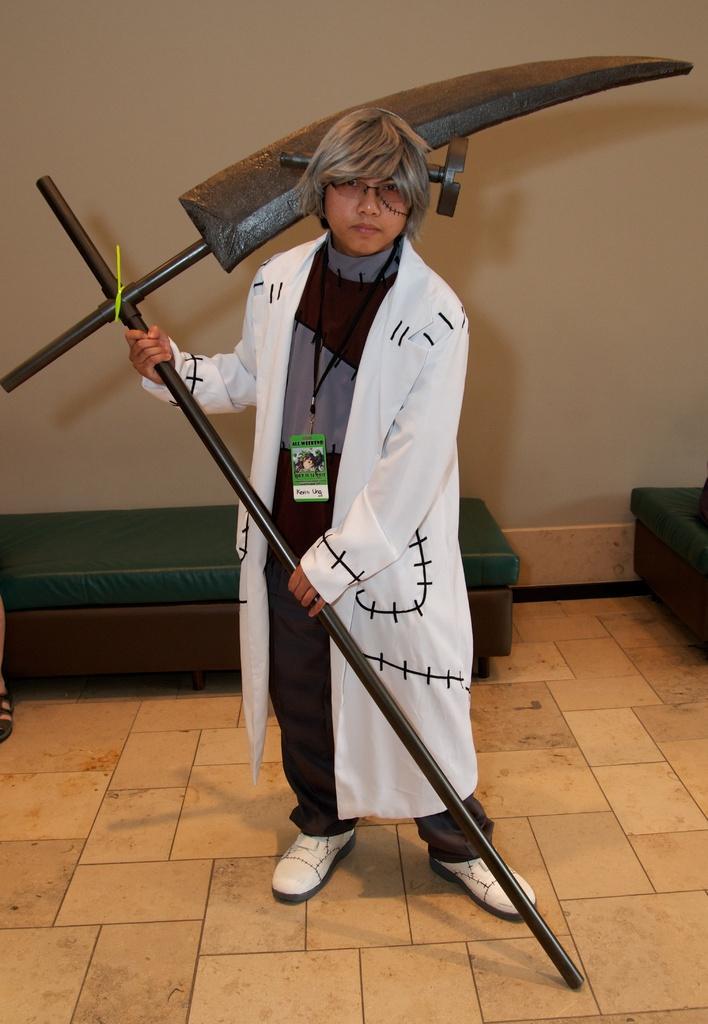Could you give a brief overview of what you see in this image? In the middle of the image a person is standing and holding some weapon in his hand. Behind him there are some tables. At the top of the image there is wall. 